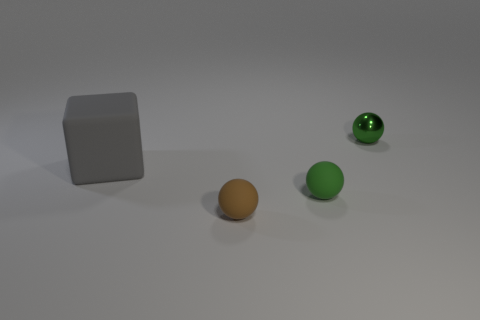Subtract all purple spheres. Subtract all yellow blocks. How many spheres are left? 3 Add 1 tiny green rubber spheres. How many objects exist? 5 Subtract all balls. How many objects are left? 1 Add 2 green metal spheres. How many green metal spheres exist? 3 Subtract 0 blue cubes. How many objects are left? 4 Subtract all tiny green shiny spheres. Subtract all blue spheres. How many objects are left? 3 Add 3 shiny spheres. How many shiny spheres are left? 4 